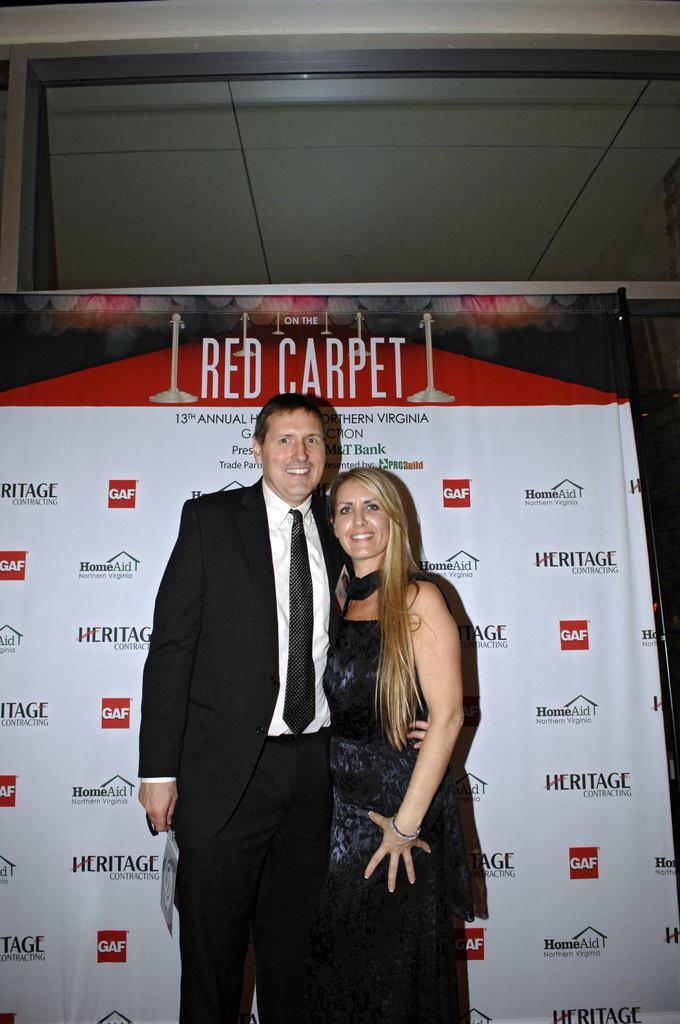How would you summarize this image in a sentence or two? In this image we can see two people standing and behind there is a written text on the board, near that we can see the glass object. 